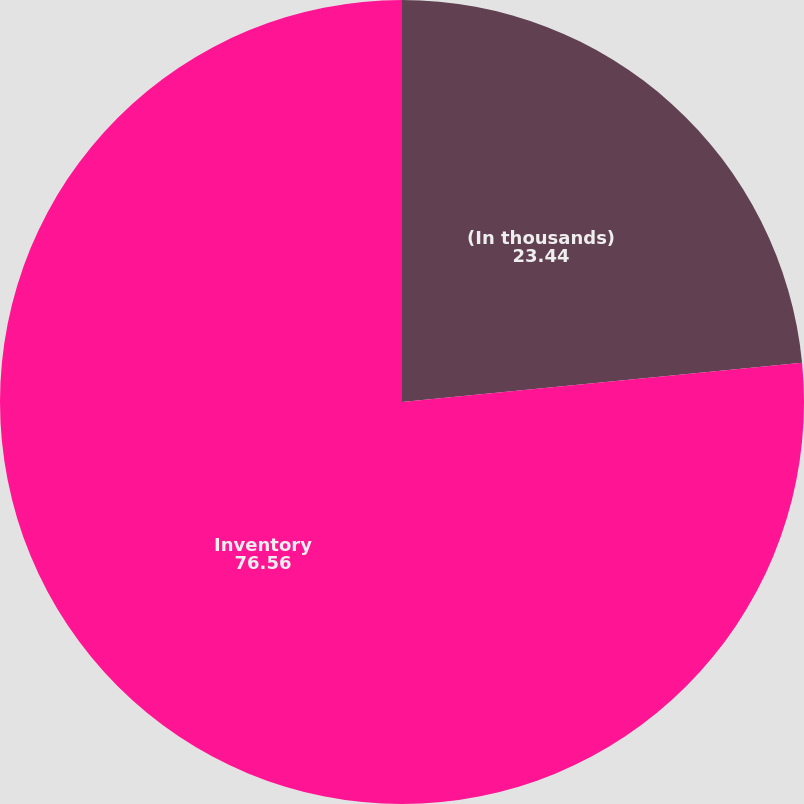Convert chart. <chart><loc_0><loc_0><loc_500><loc_500><pie_chart><fcel>(In thousands)<fcel>Inventory<nl><fcel>23.44%<fcel>76.56%<nl></chart> 